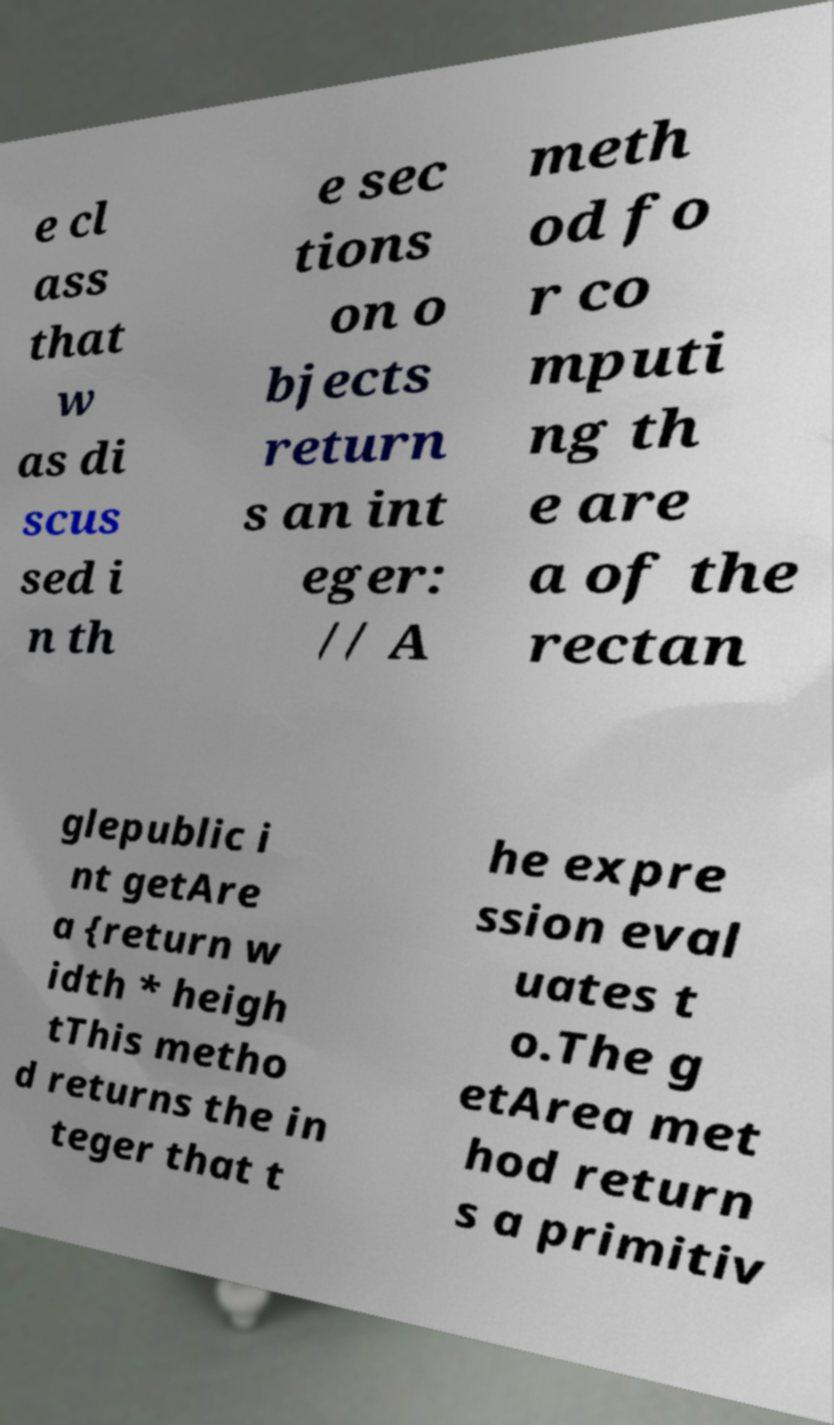For documentation purposes, I need the text within this image transcribed. Could you provide that? e cl ass that w as di scus sed i n th e sec tions on o bjects return s an int eger: // A meth od fo r co mputi ng th e are a of the rectan glepublic i nt getAre a {return w idth * heigh tThis metho d returns the in teger that t he expre ssion eval uates t o.The g etArea met hod return s a primitiv 